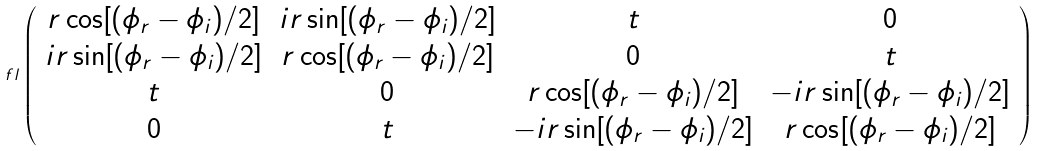<formula> <loc_0><loc_0><loc_500><loc_500>\ f l \left ( \begin{array} { c c c c } r \cos [ ( \phi _ { r } - \phi _ { i } ) / 2 ] & i r \sin [ ( \phi _ { r } - \phi _ { i } ) / 2 ] & t & 0 \\ i r \sin [ ( \phi _ { r } - \phi _ { i } ) / 2 ] & r \cos [ ( \phi _ { r } - \phi _ { i } ) / 2 ] & 0 & t \\ t & 0 & r \cos [ ( \phi _ { r } - \phi _ { i } ) / 2 ] & - i r \sin [ ( \phi _ { r } - \phi _ { i } ) / 2 ] \\ 0 & t & - i r \sin [ ( \phi _ { r } - \phi _ { i } ) / 2 ] & r \cos [ ( \phi _ { r } - \phi _ { i } ) / 2 ] \end{array} \right )</formula> 